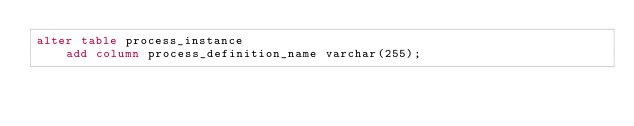Convert code to text. <code><loc_0><loc_0><loc_500><loc_500><_SQL_>alter table process_instance
    add column process_definition_name varchar(255);
    </code> 